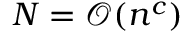<formula> <loc_0><loc_0><loc_500><loc_500>N = \mathcal { O } ( n ^ { c } )</formula> 